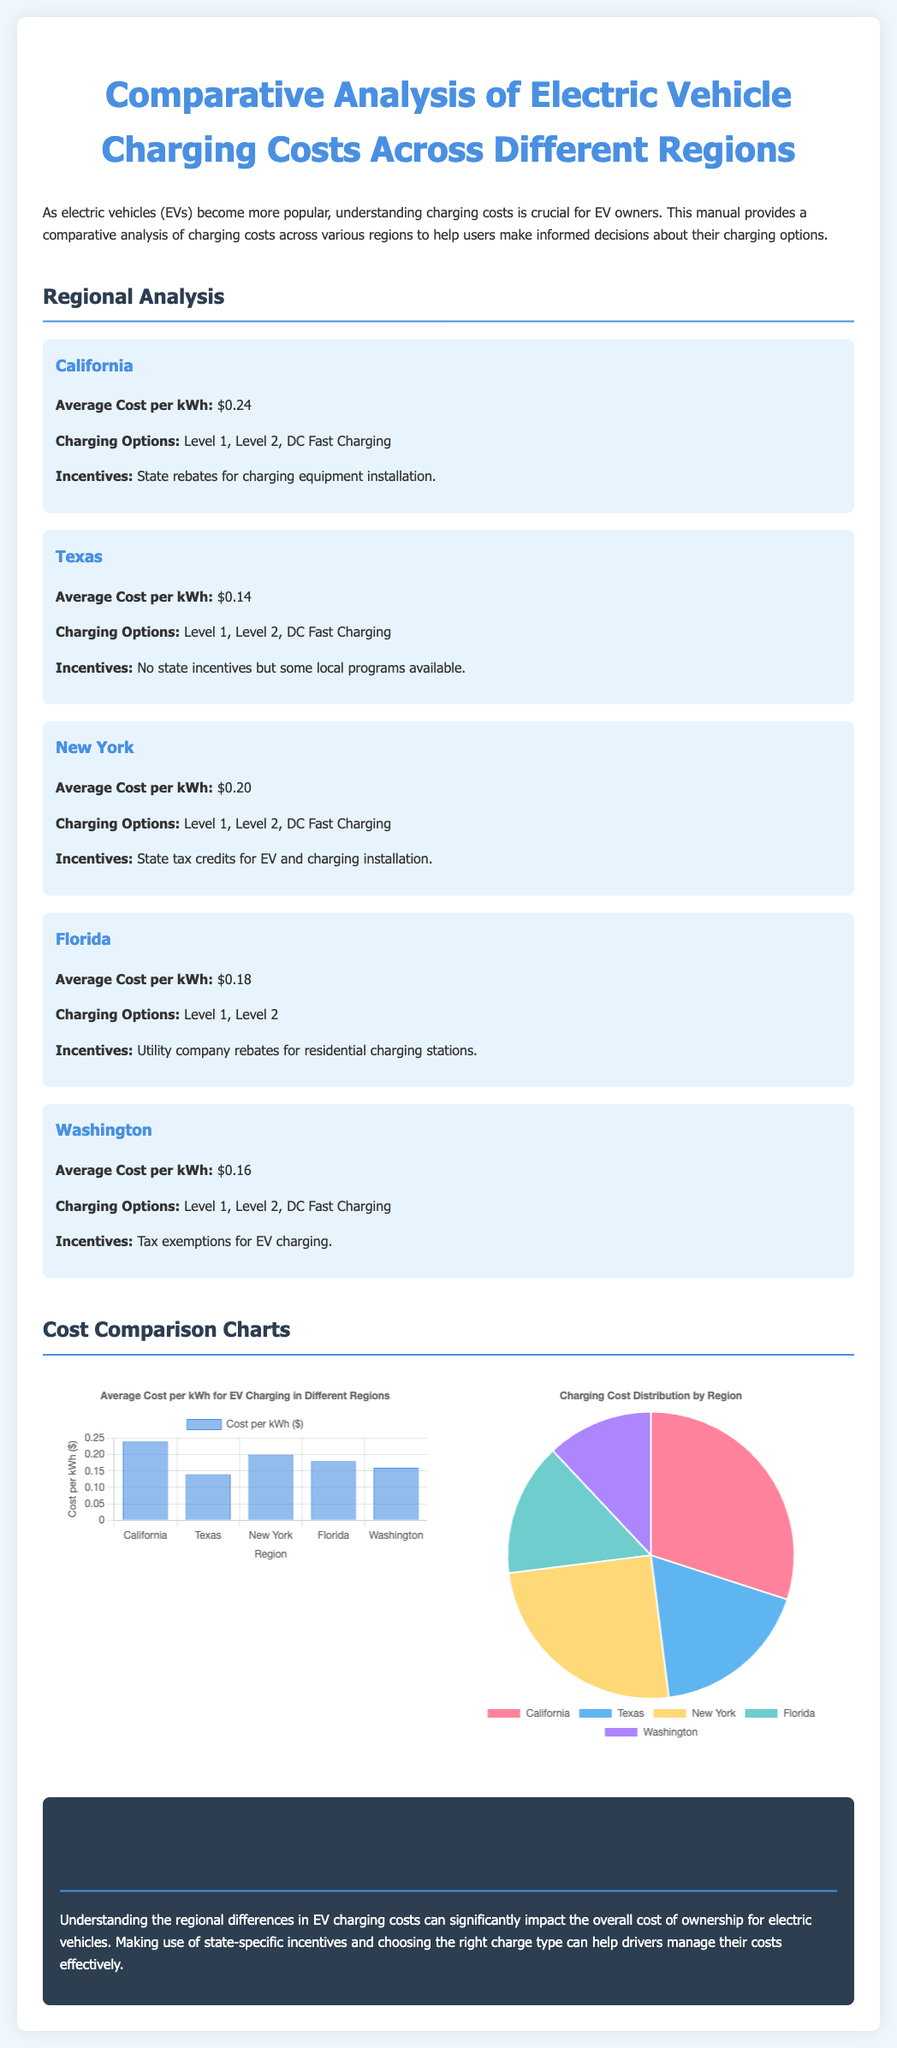what is the average cost per kWh in California? The average cost per kWh in California is stated in the regional analysis section.
Answer: $0.24 which charging options are available in Florida? The charging options for Florida are listed in the regional analysis section.
Answer: Level 1, Level 2 what incentive is provided in New York? The incentives for New York are mentioned in the regional analysis section.
Answer: State tax credits for EV and charging installation what is the average cost per kWh in Texas? The average cost in Texas is detailed in the regional analysis section.
Answer: $0.14 which region has the highest average cost per kWh? The region with the highest average cost per kWh can be inferred from the cost comparison chart data.
Answer: California how many total regions are analyzed in the document? The total number of regions is seen in the regional analysis section.
Answer: 5 what type of chart is used for the cost distribution? The document specifies the type of chart used for distribution comparisons.
Answer: Pie what is the conclusion's main focus? The main focus of the conclusion summarizes insights from the regional analysis.
Answer: Regional differences in EV charging costs what is the average cost per kWh in Washington? The specific average cost for Washington is highlighted in the regional analysis section.
Answer: $0.16 